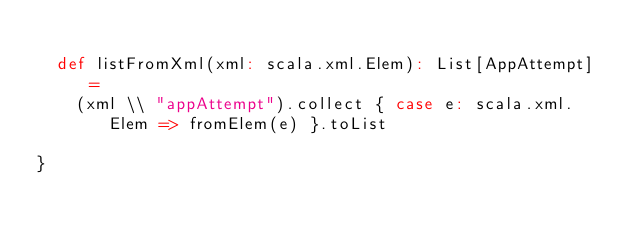Convert code to text. <code><loc_0><loc_0><loc_500><loc_500><_Scala_>
  def listFromXml(xml: scala.xml.Elem): List[AppAttempt] =
    (xml \\ "appAttempt").collect { case e: scala.xml.Elem => fromElem(e) }.toList

}
</code> 